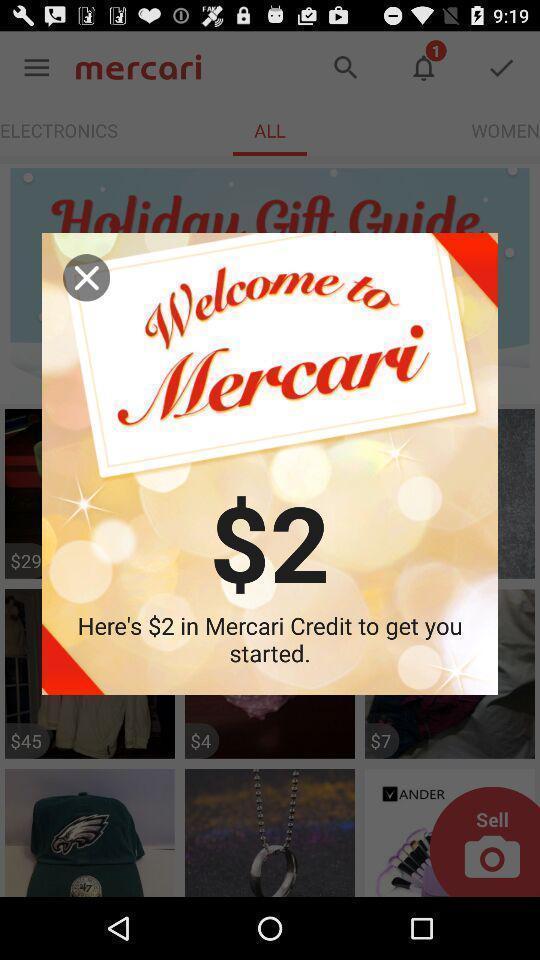Give me a summary of this screen capture. Pop-up showing welcome message and credit amount information. 